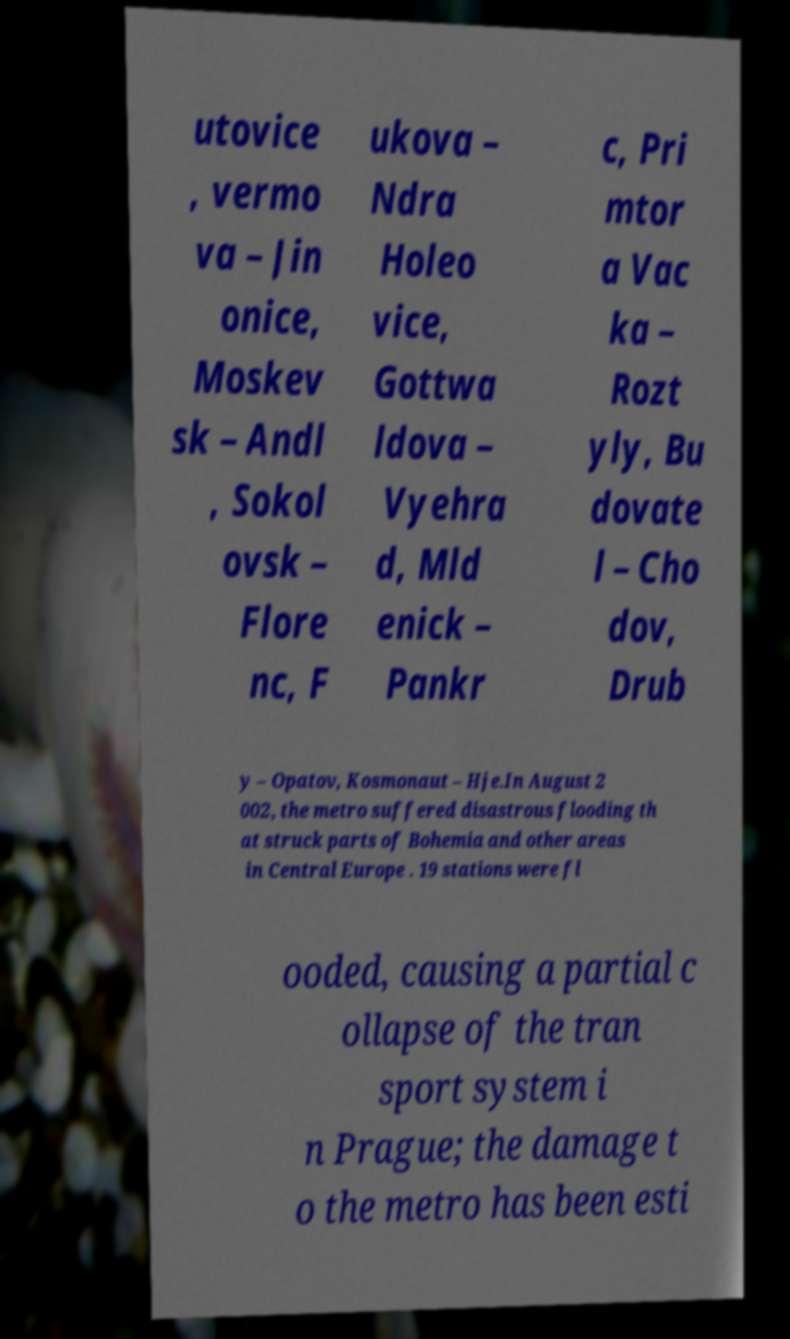I need the written content from this picture converted into text. Can you do that? utovice , vermo va – Jin onice, Moskev sk – Andl , Sokol ovsk – Flore nc, F ukova – Ndra Holeo vice, Gottwa ldova – Vyehra d, Mld enick – Pankr c, Pri mtor a Vac ka – Rozt yly, Bu dovate l – Cho dov, Drub y – Opatov, Kosmonaut – Hje.In August 2 002, the metro suffered disastrous flooding th at struck parts of Bohemia and other areas in Central Europe . 19 stations were fl ooded, causing a partial c ollapse of the tran sport system i n Prague; the damage t o the metro has been esti 